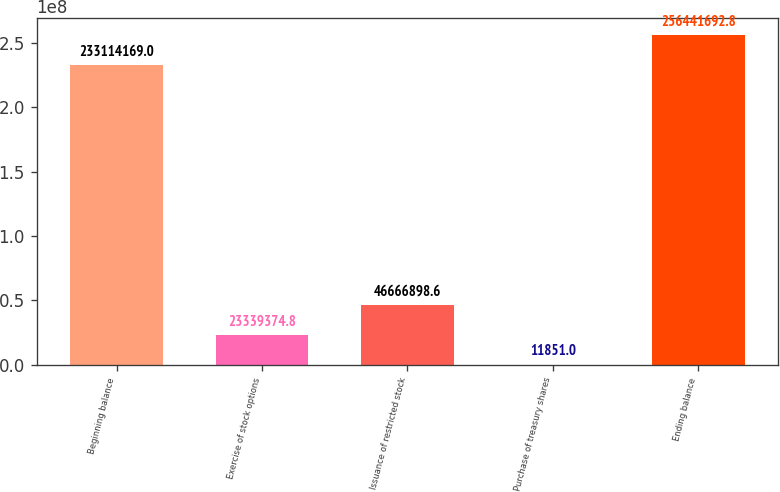<chart> <loc_0><loc_0><loc_500><loc_500><bar_chart><fcel>Beginning balance<fcel>Exercise of stock options<fcel>Issuance of restricted stock<fcel>Purchase of treasury shares<fcel>Ending balance<nl><fcel>2.33114e+08<fcel>2.33394e+07<fcel>4.66669e+07<fcel>11851<fcel>2.56442e+08<nl></chart> 